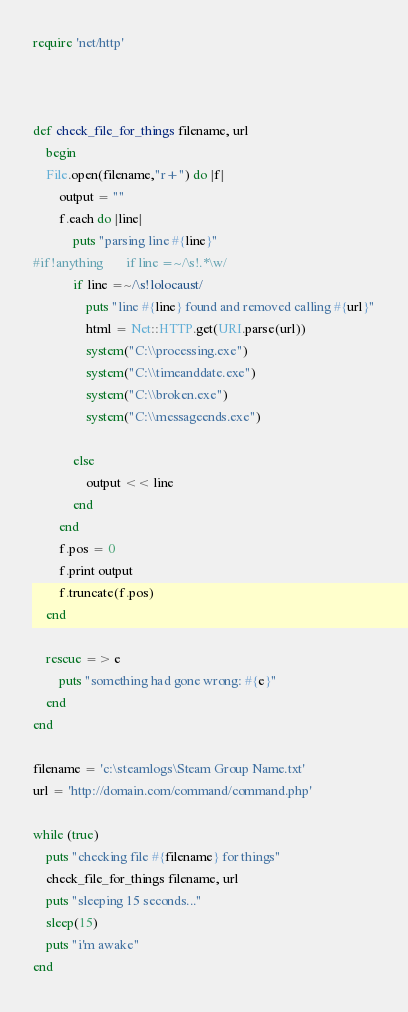<code> <loc_0><loc_0><loc_500><loc_500><_Ruby_>require 'net/http'



def check_file_for_things filename, url
	begin
	File.open(filename,"r+") do |f|
		output = ""
		f.each do |line|
			puts "parsing line #{line}"
#if !anything		if line =~/\s!.*\w/
			if line =~/\s!lolocaust/
				puts "line #{line} found and removed calling #{url}"
				html = Net::HTTP.get(URI.parse(url))
				system("C:\\processing.exe")
				system("C:\\timeanddate.exe")				
				system("C:\\broken.exe")
				system("C:\\messageends.exe")

			else
				output << line
			end
		end
		f.pos = 0                     
		f.print output
		f.truncate(f.pos)   
	end

	rescue => e
		puts "something had gone wrong: #{e}"
	end
end

filename = 'c:\steamlogs\Steam Group Name.txt'
url = 'http://domain.com/command/command.php'

while (true)
	puts "checking file #{filename} for things"
	check_file_for_things filename, url
	puts "sleeping 15 seconds..."
	sleep(15)
	puts "i'm awake"
end</code> 